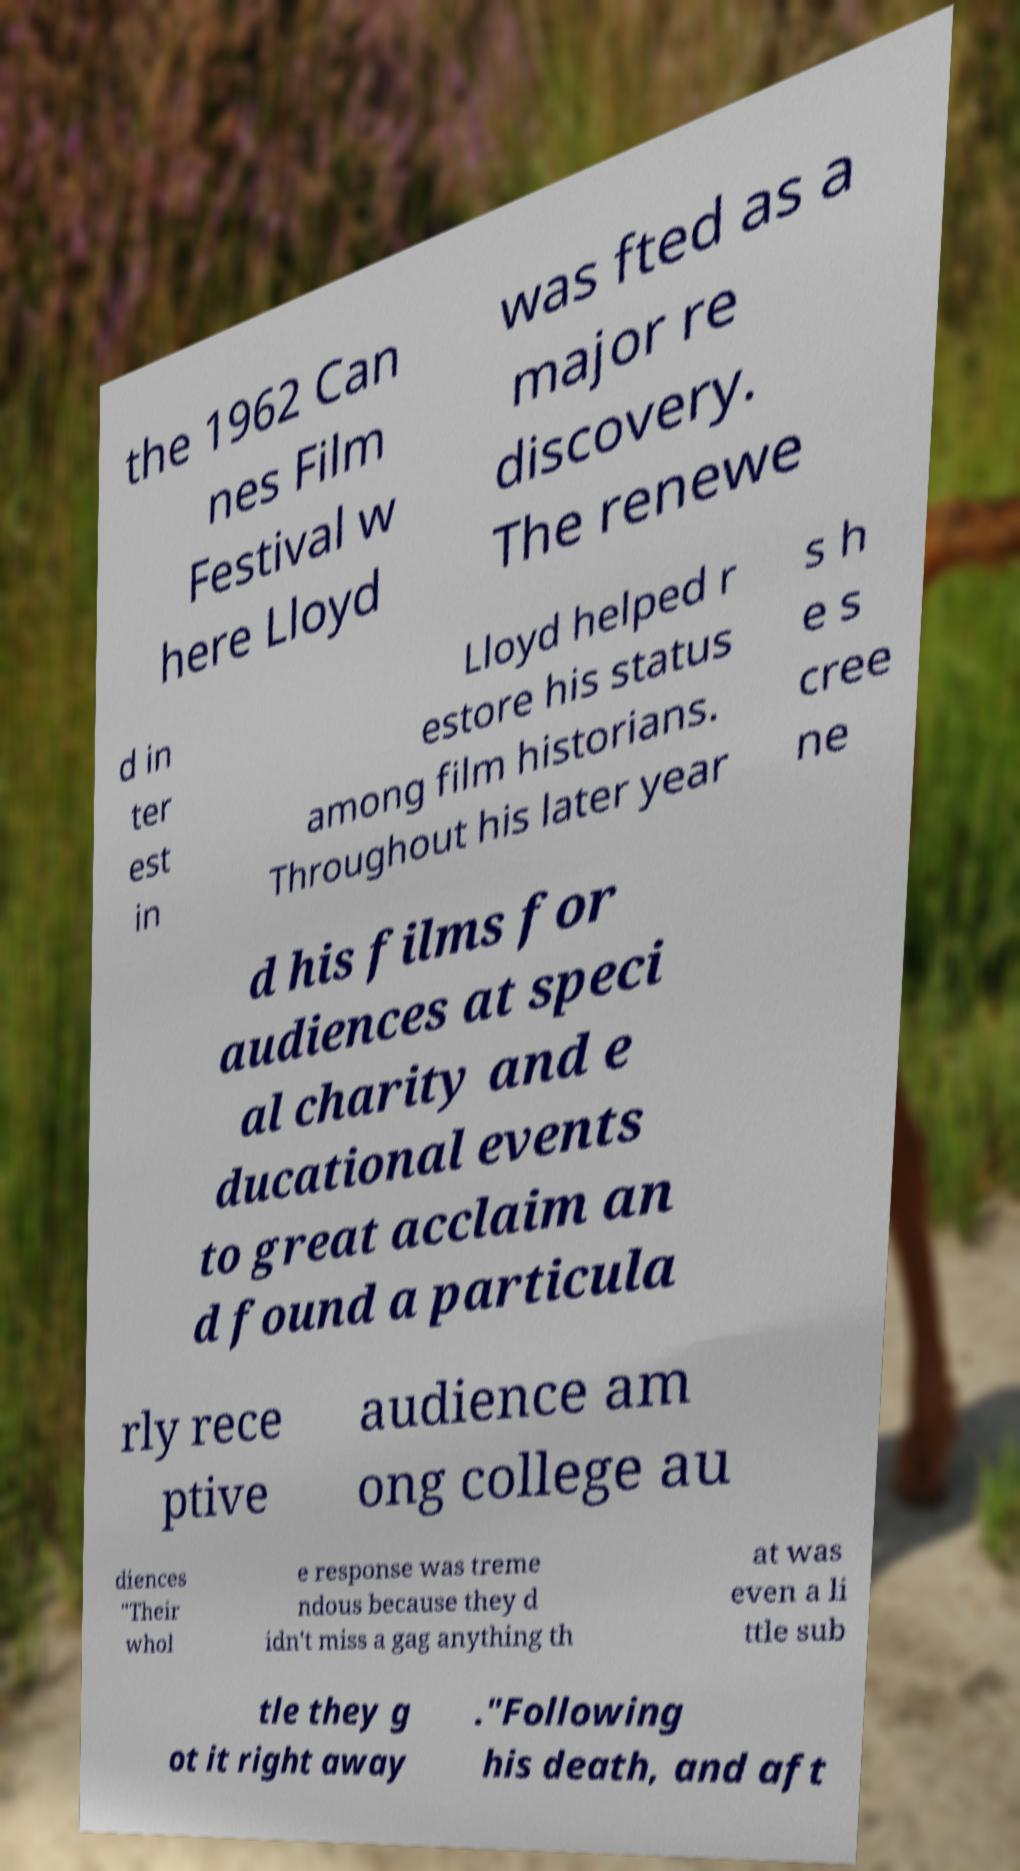Could you assist in decoding the text presented in this image and type it out clearly? the 1962 Can nes Film Festival w here Lloyd was fted as a major re discovery. The renewe d in ter est in Lloyd helped r estore his status among film historians. Throughout his later year s h e s cree ne d his films for audiences at speci al charity and e ducational events to great acclaim an d found a particula rly rece ptive audience am ong college au diences "Their whol e response was treme ndous because they d idn't miss a gag anything th at was even a li ttle sub tle they g ot it right away ."Following his death, and aft 